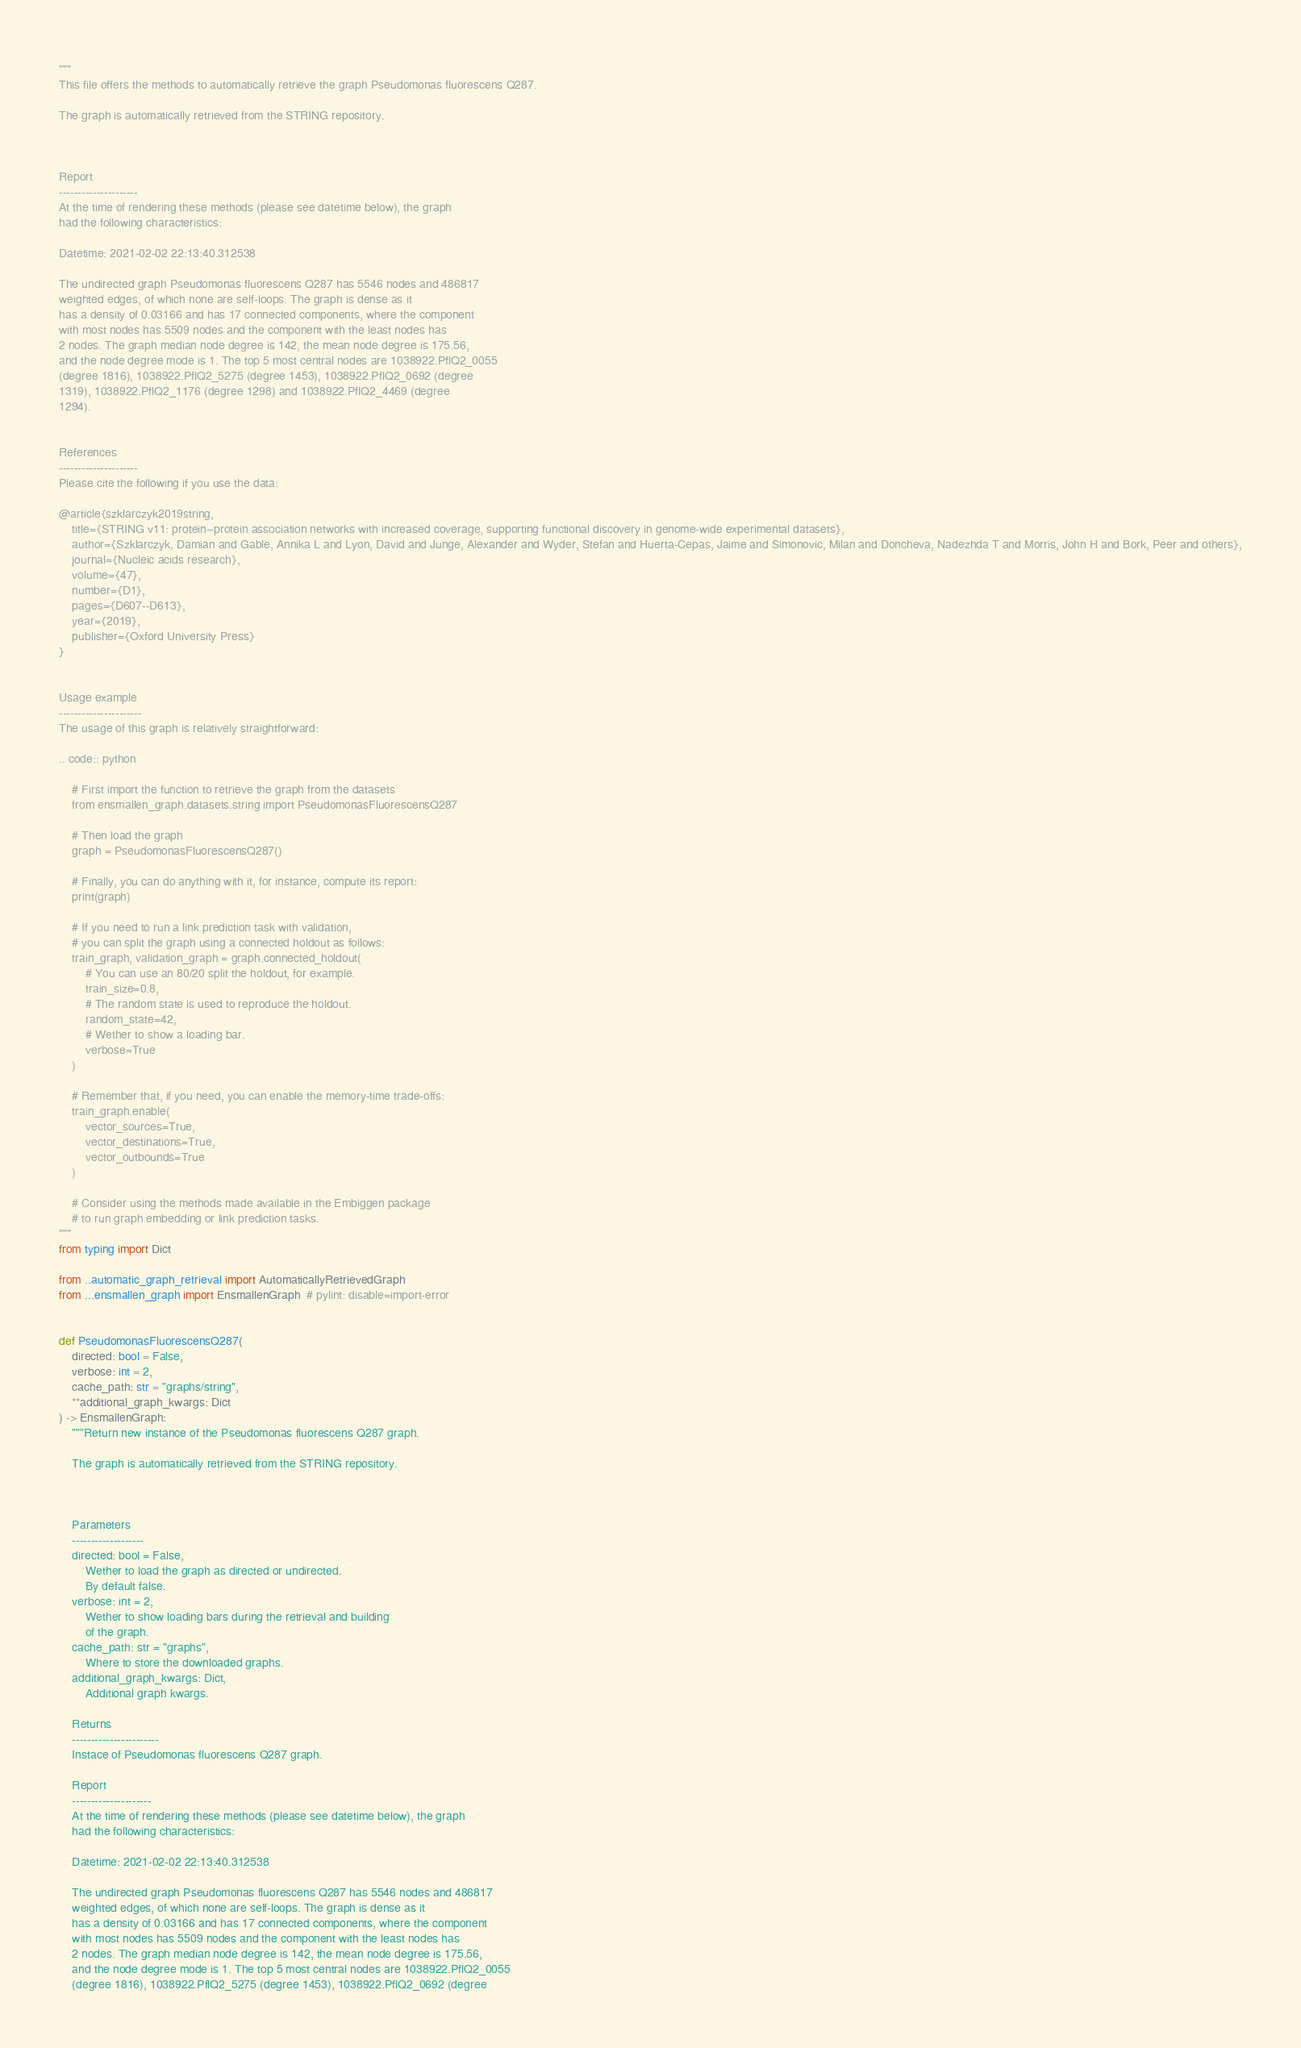<code> <loc_0><loc_0><loc_500><loc_500><_Python_>"""
This file offers the methods to automatically retrieve the graph Pseudomonas fluorescens Q287.

The graph is automatically retrieved from the STRING repository. 



Report
---------------------
At the time of rendering these methods (please see datetime below), the graph
had the following characteristics:

Datetime: 2021-02-02 22:13:40.312538

The undirected graph Pseudomonas fluorescens Q287 has 5546 nodes and 486817
weighted edges, of which none are self-loops. The graph is dense as it
has a density of 0.03166 and has 17 connected components, where the component
with most nodes has 5509 nodes and the component with the least nodes has
2 nodes. The graph median node degree is 142, the mean node degree is 175.56,
and the node degree mode is 1. The top 5 most central nodes are 1038922.PflQ2_0055
(degree 1816), 1038922.PflQ2_5275 (degree 1453), 1038922.PflQ2_0692 (degree
1319), 1038922.PflQ2_1176 (degree 1298) and 1038922.PflQ2_4469 (degree
1294).


References
---------------------
Please cite the following if you use the data:

@article{szklarczyk2019string,
    title={STRING v11: protein--protein association networks with increased coverage, supporting functional discovery in genome-wide experimental datasets},
    author={Szklarczyk, Damian and Gable, Annika L and Lyon, David and Junge, Alexander and Wyder, Stefan and Huerta-Cepas, Jaime and Simonovic, Milan and Doncheva, Nadezhda T and Morris, John H and Bork, Peer and others},
    journal={Nucleic acids research},
    volume={47},
    number={D1},
    pages={D607--D613},
    year={2019},
    publisher={Oxford University Press}
}


Usage example
----------------------
The usage of this graph is relatively straightforward:

.. code:: python

    # First import the function to retrieve the graph from the datasets
    from ensmallen_graph.datasets.string import PseudomonasFluorescensQ287

    # Then load the graph
    graph = PseudomonasFluorescensQ287()

    # Finally, you can do anything with it, for instance, compute its report:
    print(graph)

    # If you need to run a link prediction task with validation,
    # you can split the graph using a connected holdout as follows:
    train_graph, validation_graph = graph.connected_holdout(
        # You can use an 80/20 split the holdout, for example.
        train_size=0.8,
        # The random state is used to reproduce the holdout.
        random_state=42,
        # Wether to show a loading bar.
        verbose=True
    )

    # Remember that, if you need, you can enable the memory-time trade-offs:
    train_graph.enable(
        vector_sources=True,
        vector_destinations=True,
        vector_outbounds=True
    )

    # Consider using the methods made available in the Embiggen package
    # to run graph embedding or link prediction tasks.
"""
from typing import Dict

from ..automatic_graph_retrieval import AutomaticallyRetrievedGraph
from ...ensmallen_graph import EnsmallenGraph  # pylint: disable=import-error


def PseudomonasFluorescensQ287(
    directed: bool = False,
    verbose: int = 2,
    cache_path: str = "graphs/string",
    **additional_graph_kwargs: Dict
) -> EnsmallenGraph:
    """Return new instance of the Pseudomonas fluorescens Q287 graph.

    The graph is automatically retrieved from the STRING repository. 

	

    Parameters
    -------------------
    directed: bool = False,
        Wether to load the graph as directed or undirected.
        By default false.
    verbose: int = 2,
        Wether to show loading bars during the retrieval and building
        of the graph.
    cache_path: str = "graphs",
        Where to store the downloaded graphs.
    additional_graph_kwargs: Dict,
        Additional graph kwargs.

    Returns
    -----------------------
    Instace of Pseudomonas fluorescens Q287 graph.

	Report
	---------------------
	At the time of rendering these methods (please see datetime below), the graph
	had the following characteristics:
	
	Datetime: 2021-02-02 22:13:40.312538
	
	The undirected graph Pseudomonas fluorescens Q287 has 5546 nodes and 486817
	weighted edges, of which none are self-loops. The graph is dense as it
	has a density of 0.03166 and has 17 connected components, where the component
	with most nodes has 5509 nodes and the component with the least nodes has
	2 nodes. The graph median node degree is 142, the mean node degree is 175.56,
	and the node degree mode is 1. The top 5 most central nodes are 1038922.PflQ2_0055
	(degree 1816), 1038922.PflQ2_5275 (degree 1453), 1038922.PflQ2_0692 (degree</code> 